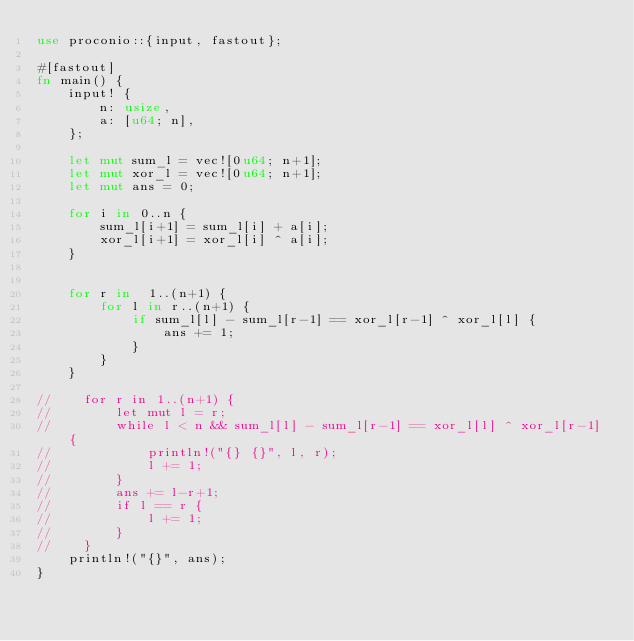Convert code to text. <code><loc_0><loc_0><loc_500><loc_500><_Rust_>use proconio::{input, fastout};

#[fastout]
fn main() {
    input! {
        n: usize,
        a: [u64; n],
    };

    let mut sum_l = vec![0u64; n+1];
    let mut xor_l = vec![0u64; n+1];
    let mut ans = 0;

    for i in 0..n {
        sum_l[i+1] = sum_l[i] + a[i];
        xor_l[i+1] = xor_l[i] ^ a[i];
    }


    for r in  1..(n+1) {
        for l in r..(n+1) {
            if sum_l[l] - sum_l[r-1] == xor_l[r-1] ^ xor_l[l] {
                ans += 1;
            }
        }
    }

//    for r in 1..(n+1) {
//        let mut l = r;
//        while l < n && sum_l[l] - sum_l[r-1] == xor_l[l] ^ xor_l[r-1] {
//            println!("{} {}", l, r);
//            l += 1;
//        }
//        ans += l-r+1;
//        if l == r {
//            l += 1;
//        }
//    }
    println!("{}", ans);
}
</code> 